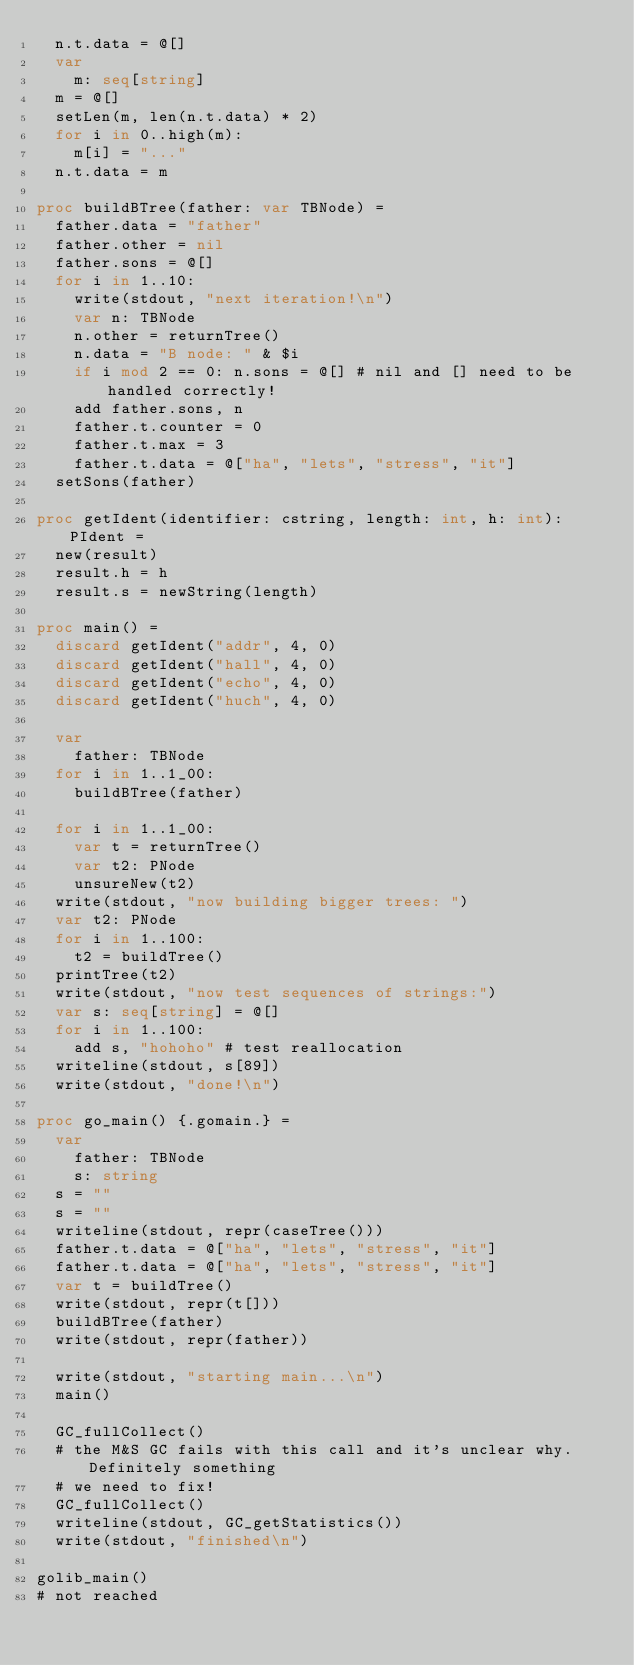<code> <loc_0><loc_0><loc_500><loc_500><_Nim_>  n.t.data = @[]
  var
    m: seq[string]
  m = @[]
  setLen(m, len(n.t.data) * 2)
  for i in 0..high(m):
    m[i] = "..."
  n.t.data = m

proc buildBTree(father: var TBNode) =
  father.data = "father"
  father.other = nil
  father.sons = @[]
  for i in 1..10:
    write(stdout, "next iteration!\n")
    var n: TBNode
    n.other = returnTree()
    n.data = "B node: " & $i
    if i mod 2 == 0: n.sons = @[] # nil and [] need to be handled correctly!
    add father.sons, n
    father.t.counter = 0
    father.t.max = 3
    father.t.data = @["ha", "lets", "stress", "it"]
  setSons(father)

proc getIdent(identifier: cstring, length: int, h: int): PIdent =
  new(result)
  result.h = h
  result.s = newString(length)

proc main() =
  discard getIdent("addr", 4, 0)
  discard getIdent("hall", 4, 0)
  discard getIdent("echo", 4, 0)
  discard getIdent("huch", 4, 0)

  var
    father: TBNode
  for i in 1..1_00:
    buildBTree(father)

  for i in 1..1_00:
    var t = returnTree()
    var t2: PNode
    unsureNew(t2)
  write(stdout, "now building bigger trees: ")
  var t2: PNode
  for i in 1..100:
    t2 = buildTree()
  printTree(t2)
  write(stdout, "now test sequences of strings:")
  var s: seq[string] = @[]
  for i in 1..100:
    add s, "hohoho" # test reallocation
  writeline(stdout, s[89])
  write(stdout, "done!\n")

proc go_main() {.gomain.} =
  var
    father: TBNode
    s: string
  s = ""
  s = ""
  writeline(stdout, repr(caseTree()))
  father.t.data = @["ha", "lets", "stress", "it"]
  father.t.data = @["ha", "lets", "stress", "it"]
  var t = buildTree()
  write(stdout, repr(t[]))
  buildBTree(father)
  write(stdout, repr(father))

  write(stdout, "starting main...\n")
  main()

  GC_fullCollect()
  # the M&S GC fails with this call and it's unclear why. Definitely something
  # we need to fix!
  GC_fullCollect()
  writeline(stdout, GC_getStatistics())
  write(stdout, "finished\n")

golib_main()
# not reached

</code> 